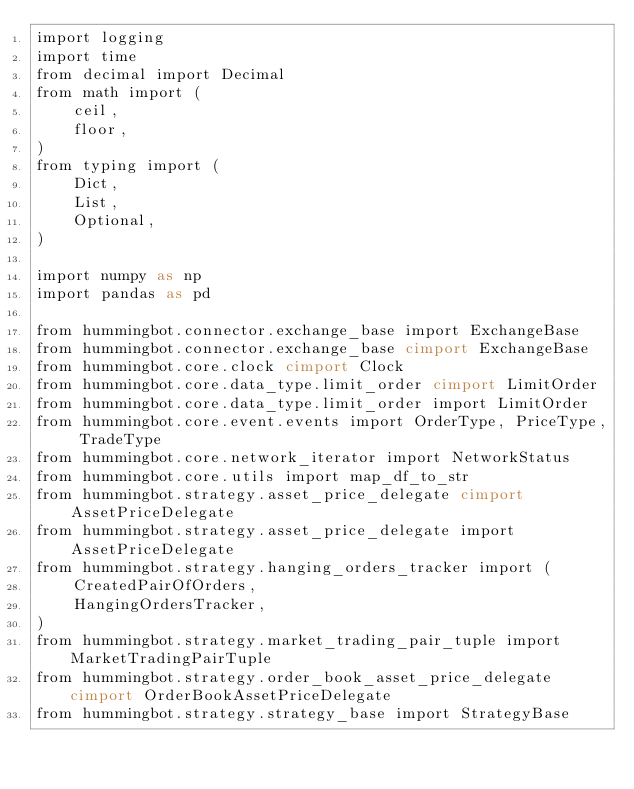Convert code to text. <code><loc_0><loc_0><loc_500><loc_500><_Cython_>import logging
import time
from decimal import Decimal
from math import (
    ceil,
    floor,
)
from typing import (
    Dict,
    List,
    Optional,
)

import numpy as np
import pandas as pd

from hummingbot.connector.exchange_base import ExchangeBase
from hummingbot.connector.exchange_base cimport ExchangeBase
from hummingbot.core.clock cimport Clock
from hummingbot.core.data_type.limit_order cimport LimitOrder
from hummingbot.core.data_type.limit_order import LimitOrder
from hummingbot.core.event.events import OrderType, PriceType, TradeType
from hummingbot.core.network_iterator import NetworkStatus
from hummingbot.core.utils import map_df_to_str
from hummingbot.strategy.asset_price_delegate cimport AssetPriceDelegate
from hummingbot.strategy.asset_price_delegate import AssetPriceDelegate
from hummingbot.strategy.hanging_orders_tracker import (
    CreatedPairOfOrders,
    HangingOrdersTracker,
)
from hummingbot.strategy.market_trading_pair_tuple import MarketTradingPairTuple
from hummingbot.strategy.order_book_asset_price_delegate cimport OrderBookAssetPriceDelegate
from hummingbot.strategy.strategy_base import StrategyBase</code> 